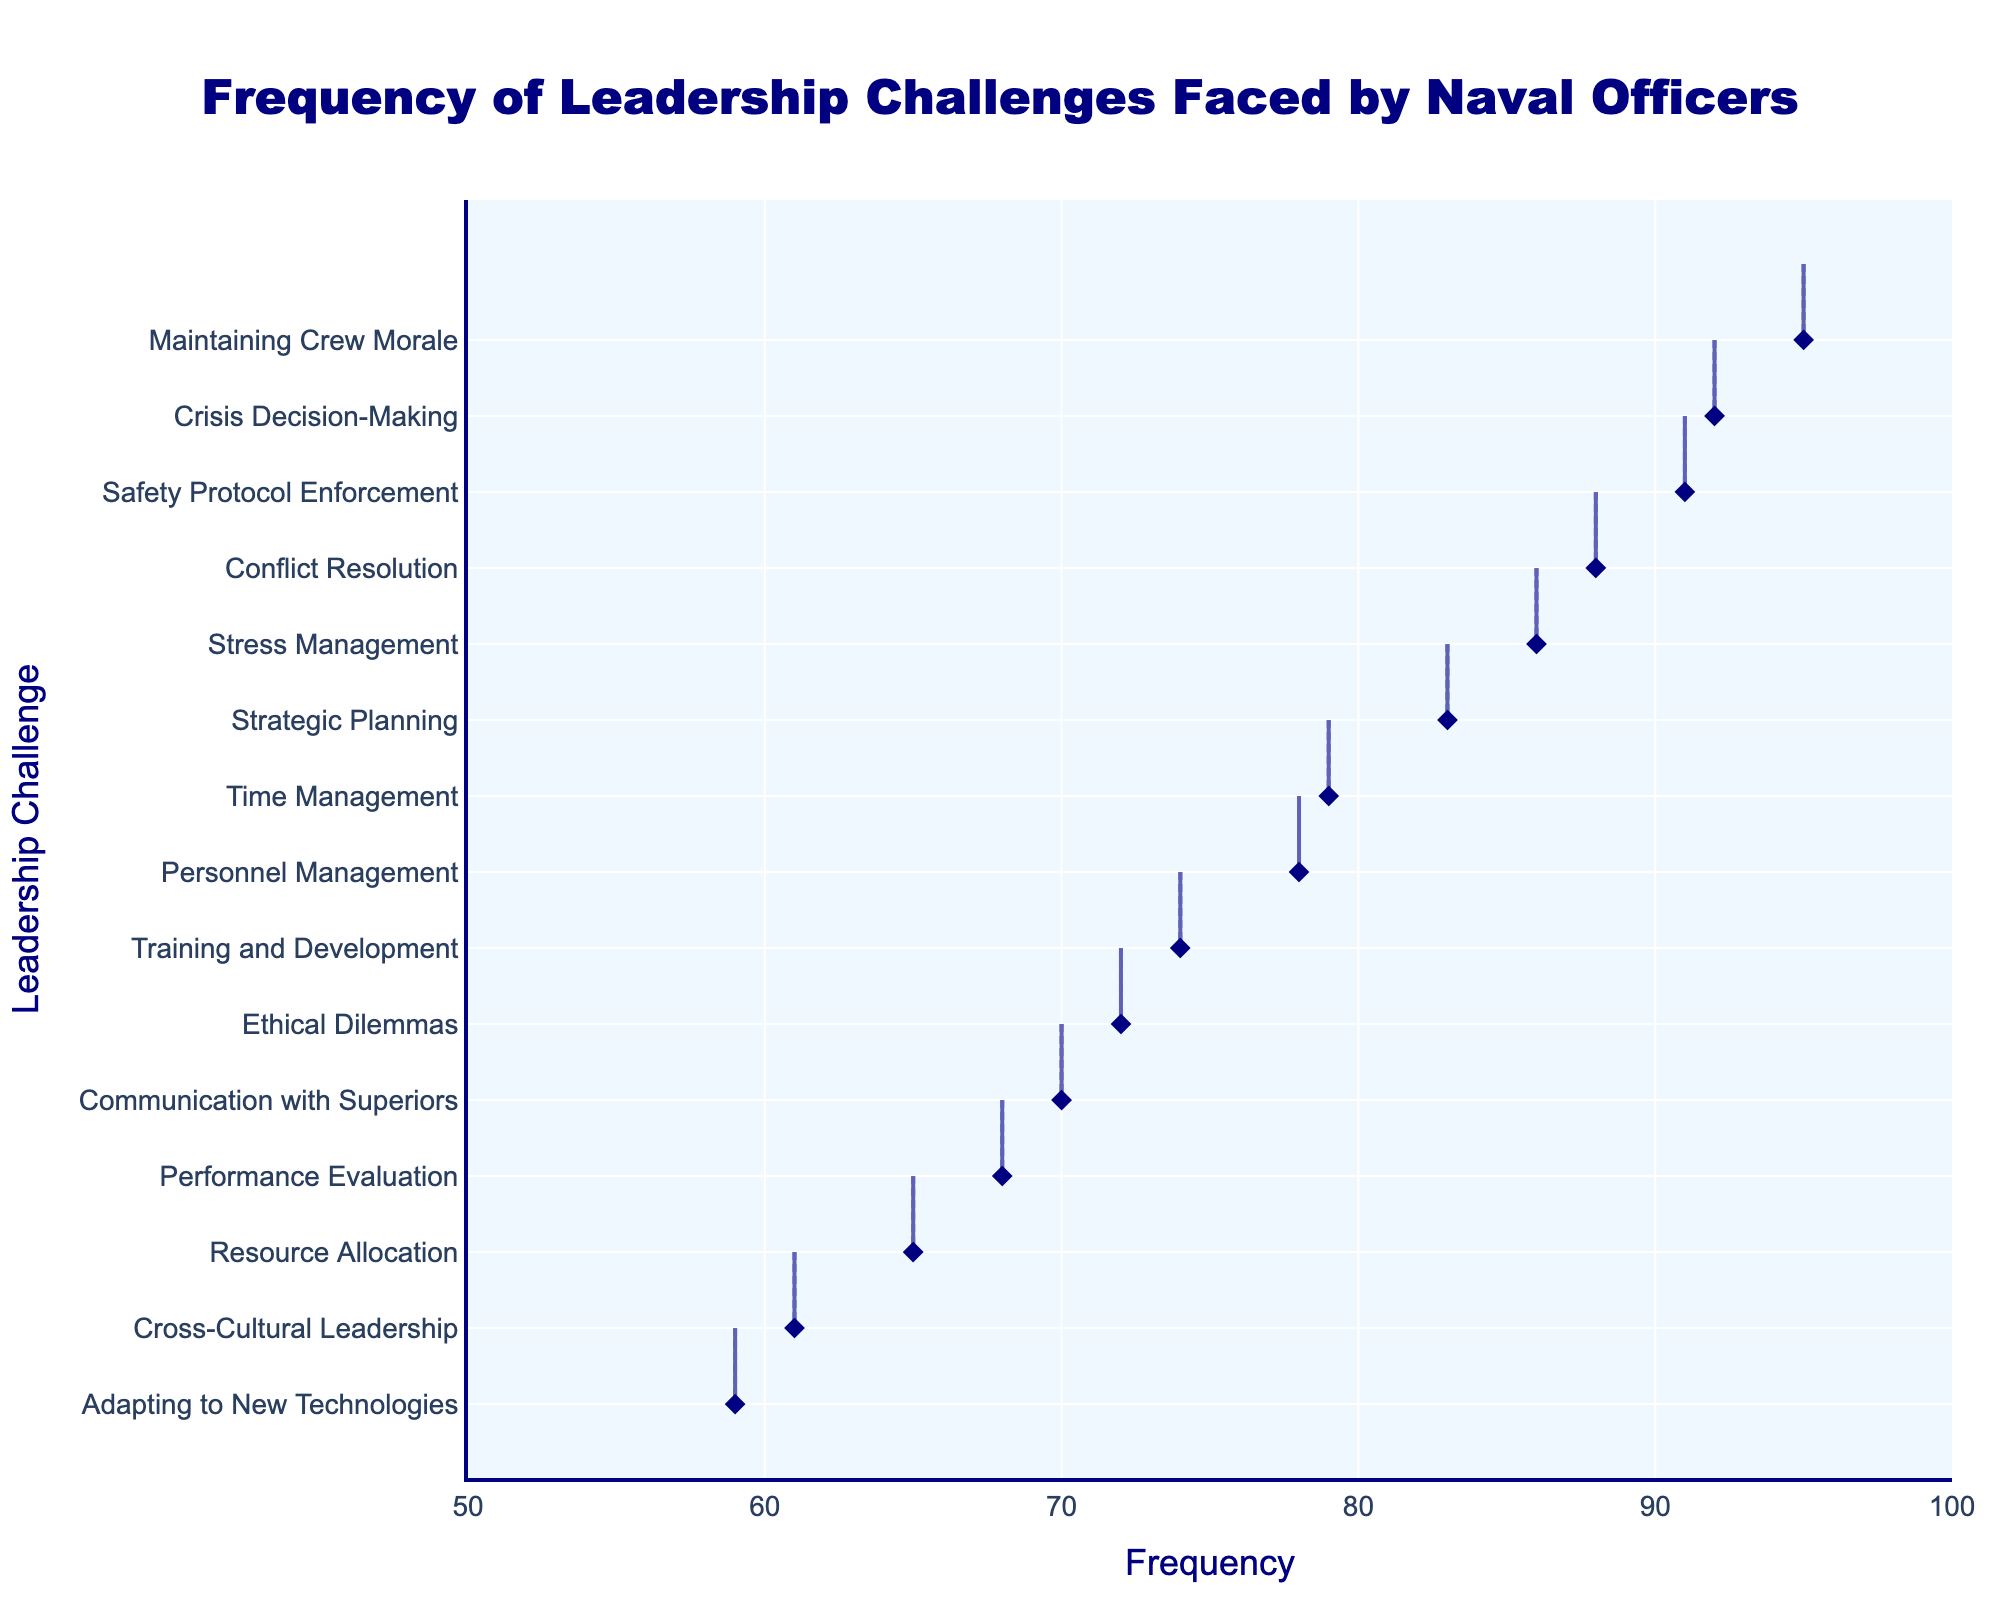what is the title of the figure? The title is meant to give an overview of what the figure represents. You would typically find the title at the top of the figure and it summarizes the content displayed.
Answer: Frequency of Leadership Challenges Faced by Naval Officers what is the maximum value on the x-axis? The x-axis labels the frequency of leadership challenges. By looking at the range marked on the x-axis, we can determine the maximum value.
Answer: 100 what color are the data points marked with? To highlight individual data points, a distinct color is often chosen. By observing these points in the figure, we can identify their color.
Answer: navy which leadership challenge has the highest frequency? The horizontal density plot allows us to visually compare the frequencies. The challenge occurring furthest to the right indicates the highest frequency.
Answer: Maintaining Crew Morale what is the mean frequency of the challenges? Calculate the total frequency by summing up the frequencies of all the challenges and then divide by the number of challenges (15).
Answer: 77.13 which two challenges have frequencies that are closest to each other? By examining the figure, we can identify challenges whose markers are positioned very closely on the x-axis.
Answer: Communication with Superiors and Ethical Dilemmas how many challenges have a frequency greater than 80? Count the number of markers or density representations that fall to the right side of 80 on the x-axis.
Answer: 7 which challenge has the lowest frequency? The challenge plotted closest to the left on the x-axis has the lowest frequency.
Answer: Adapting to New Technologies how does the frequency of "Resource Allocation" compare to "Personnel Management"? By comparing the positions of the markers for these two challenges on the x-axis, we can determine their relative frequencies.
Answer: Resource Allocation is less frequent than Personnel Management 